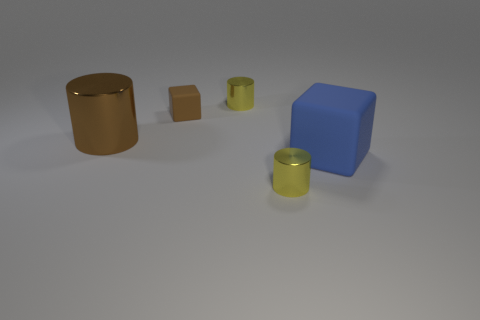Subtract all tiny yellow shiny cylinders. How many cylinders are left? 1 Add 1 yellow metal objects. How many objects exist? 6 Subtract 3 cylinders. How many cylinders are left? 0 Subtract all cyan blocks. How many yellow cylinders are left? 2 Subtract all yellow cylinders. How many cylinders are left? 1 Subtract all cyan cubes. Subtract all red balls. How many cubes are left? 2 Subtract all yellow metallic objects. Subtract all small blocks. How many objects are left? 2 Add 5 yellow things. How many yellow things are left? 7 Add 1 small yellow cylinders. How many small yellow cylinders exist? 3 Subtract 0 cyan cylinders. How many objects are left? 5 